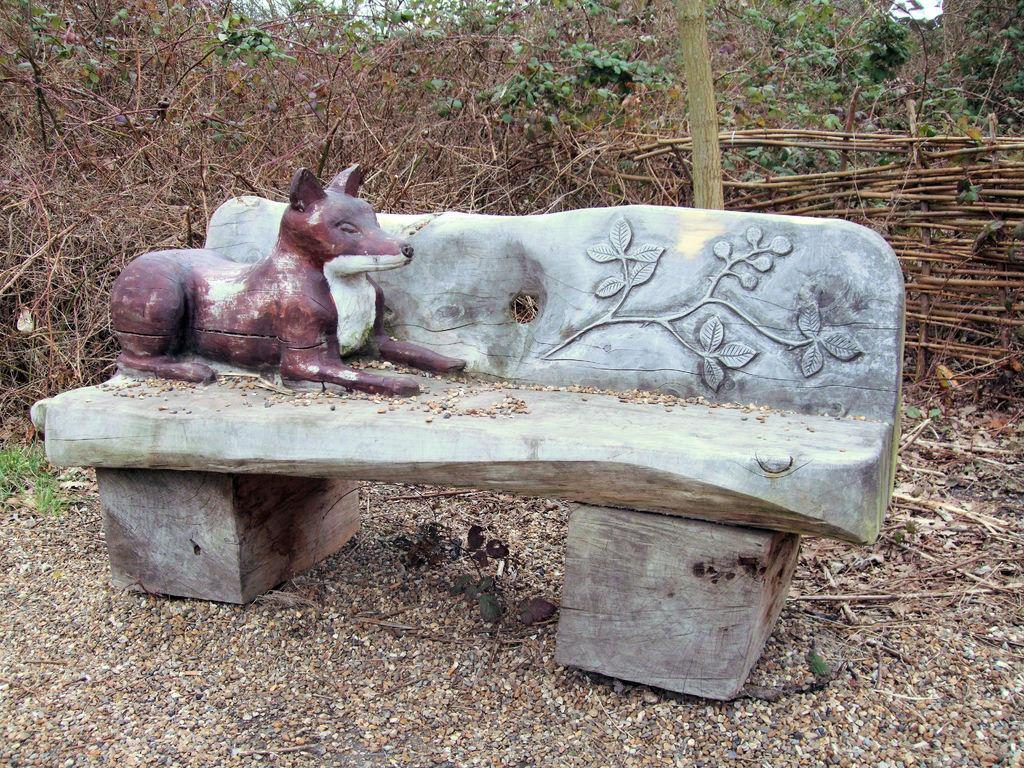What is the main subject of the image? There is a sculpture of an animal on a table in the image. Where is the table located in the image? The table is in the middle of the image. What can be seen in the background of the image? There are trees in the background of the image. How many liters of milk are being poured onto the sculpture in the image? There is no milk being poured onto the sculpture in the image. What type of nail is being used to attach the sculpture to the table in the image? There is no nail visible in the image, and the sculpture is not attached to the table. 